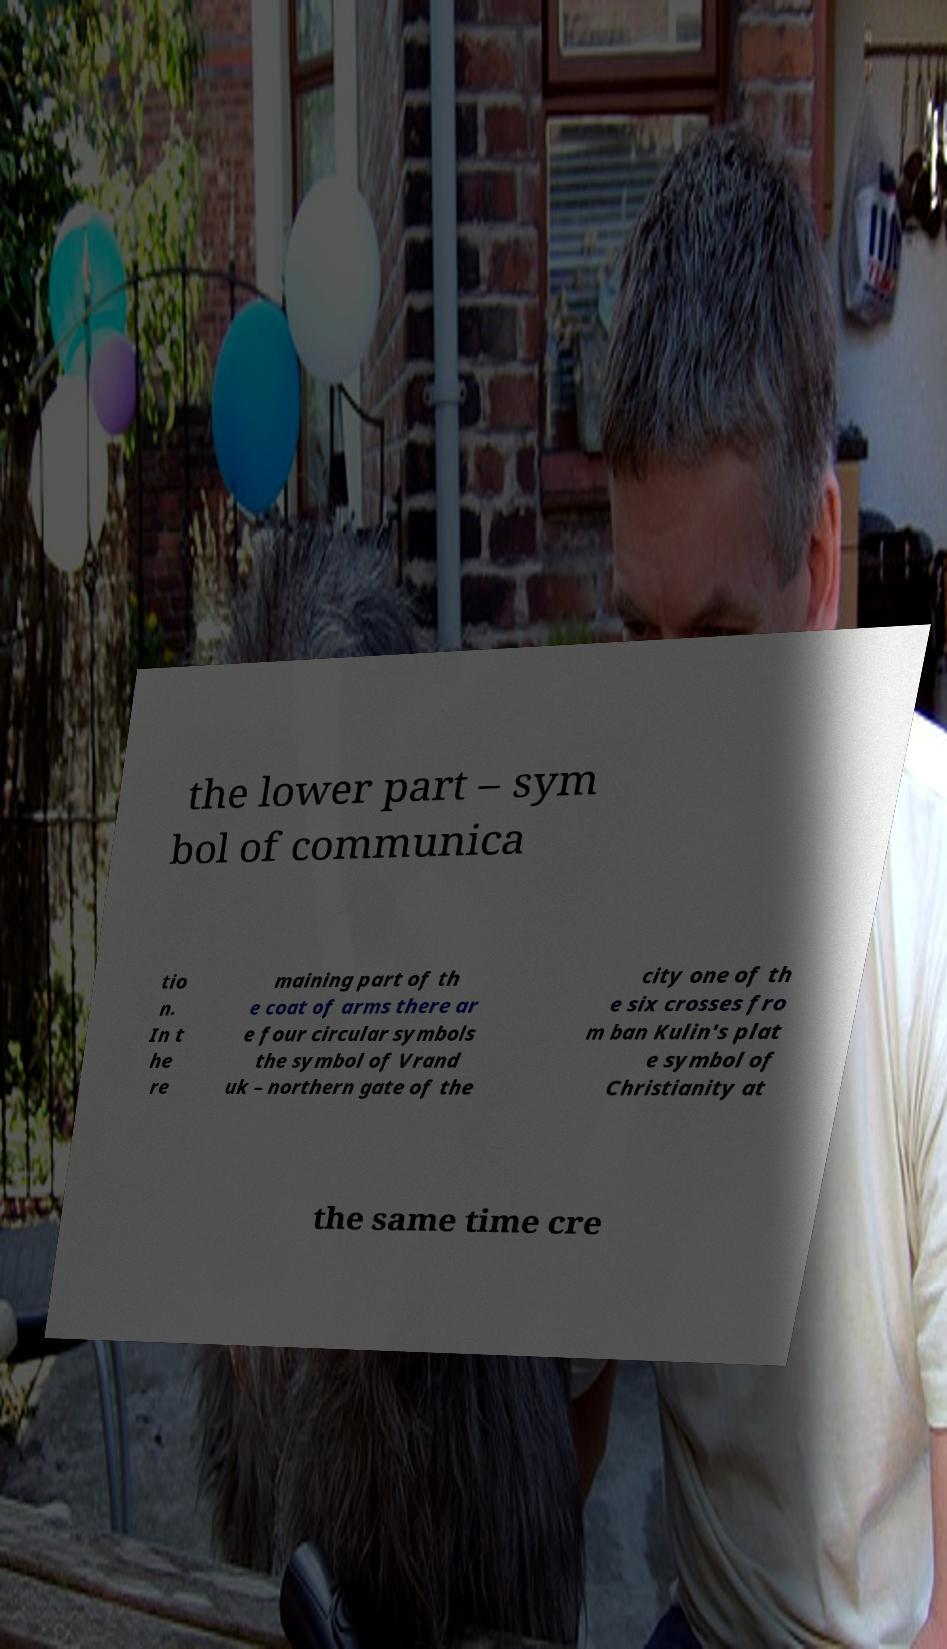Please identify and transcribe the text found in this image. the lower part – sym bol of communica tio n. In t he re maining part of th e coat of arms there ar e four circular symbols the symbol of Vrand uk – northern gate of the city one of th e six crosses fro m ban Kulin's plat e symbol of Christianity at the same time cre 